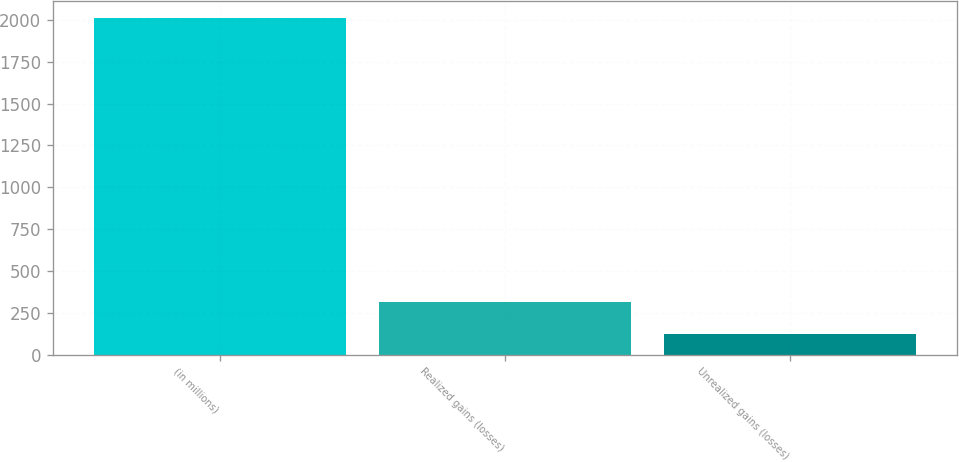Convert chart. <chart><loc_0><loc_0><loc_500><loc_500><bar_chart><fcel>(in millions)<fcel>Realized gains (losses)<fcel>Unrealized gains (losses)<nl><fcel>2012<fcel>313.7<fcel>125<nl></chart> 